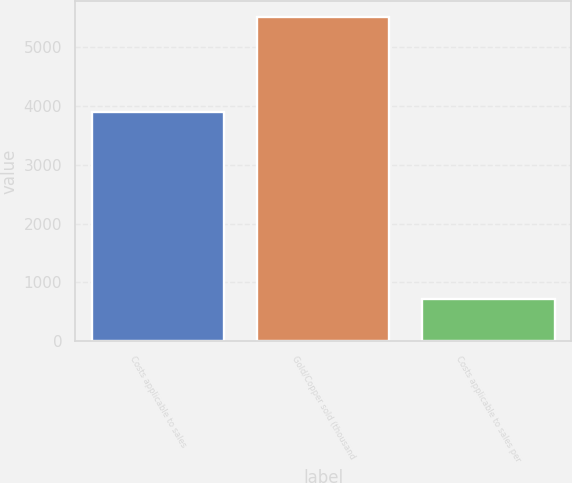Convert chart to OTSL. <chart><loc_0><loc_0><loc_500><loc_500><bar_chart><fcel>Costs applicable to sales<fcel>Gold/Copper sold (thousand<fcel>Costs applicable to sales per<nl><fcel>3906<fcel>5516<fcel>708<nl></chart> 